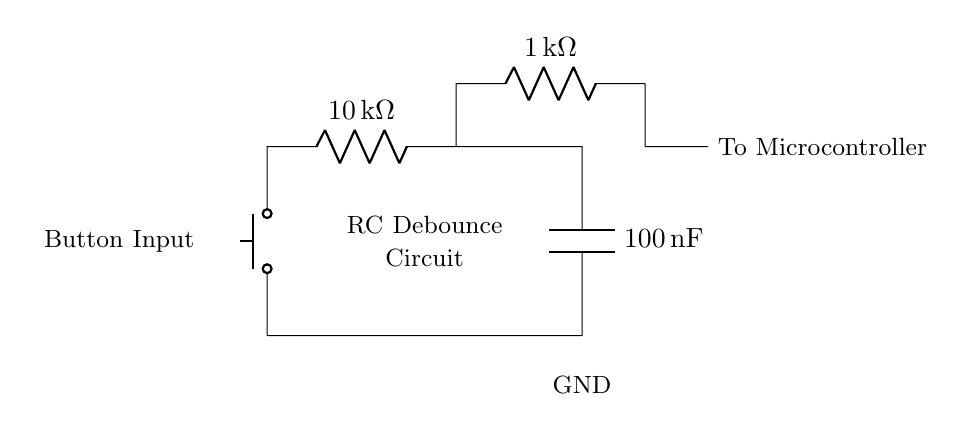What type of component is used as the input in this circuit? The circuit diagram shows a push button at the input, which is a mechanical switch.
Answer: push button What is the value of the resistor connected to the capacitor? The diagram indicates the resistor connected to the capacitor has a resistance value of ten thousand ohms.
Answer: 10 kΩ How is the capacitor connected in relation to the resistor? The capacitor is connected in parallel to the resistor in series with the button, allowing it to charge and discharge as the button is pressed and released.
Answer: in parallel What is the purpose of the capacitor in this circuit? The capacitor helps to smooth out the electrical signal generated by the button press, effectively debouncing the signal and improving accuracy.
Answer: debouncing What is the total resistance when the push button is closed? When the push button is closed, the total resistance in the circuit consists of the one thousand ohm resistor in series with the ten thousand ohm resistor, totaling eleven thousand ohms.
Answer: 11 kΩ What effect does this RC circuit have on the signal when the button is pressed? The RC circuit gradually charges the capacitor, resulting in a delayed response to the button press, which filters out any bouncing from the mechanical contacts of the switch.
Answer: delayed response What aspect of the circuit primarily determines the debounce time? The debounce time is primarily determined by the values of the resistor and capacitor, as they dictate how quickly the capacitor charges and discharges through the resistor.
Answer: R and C values 